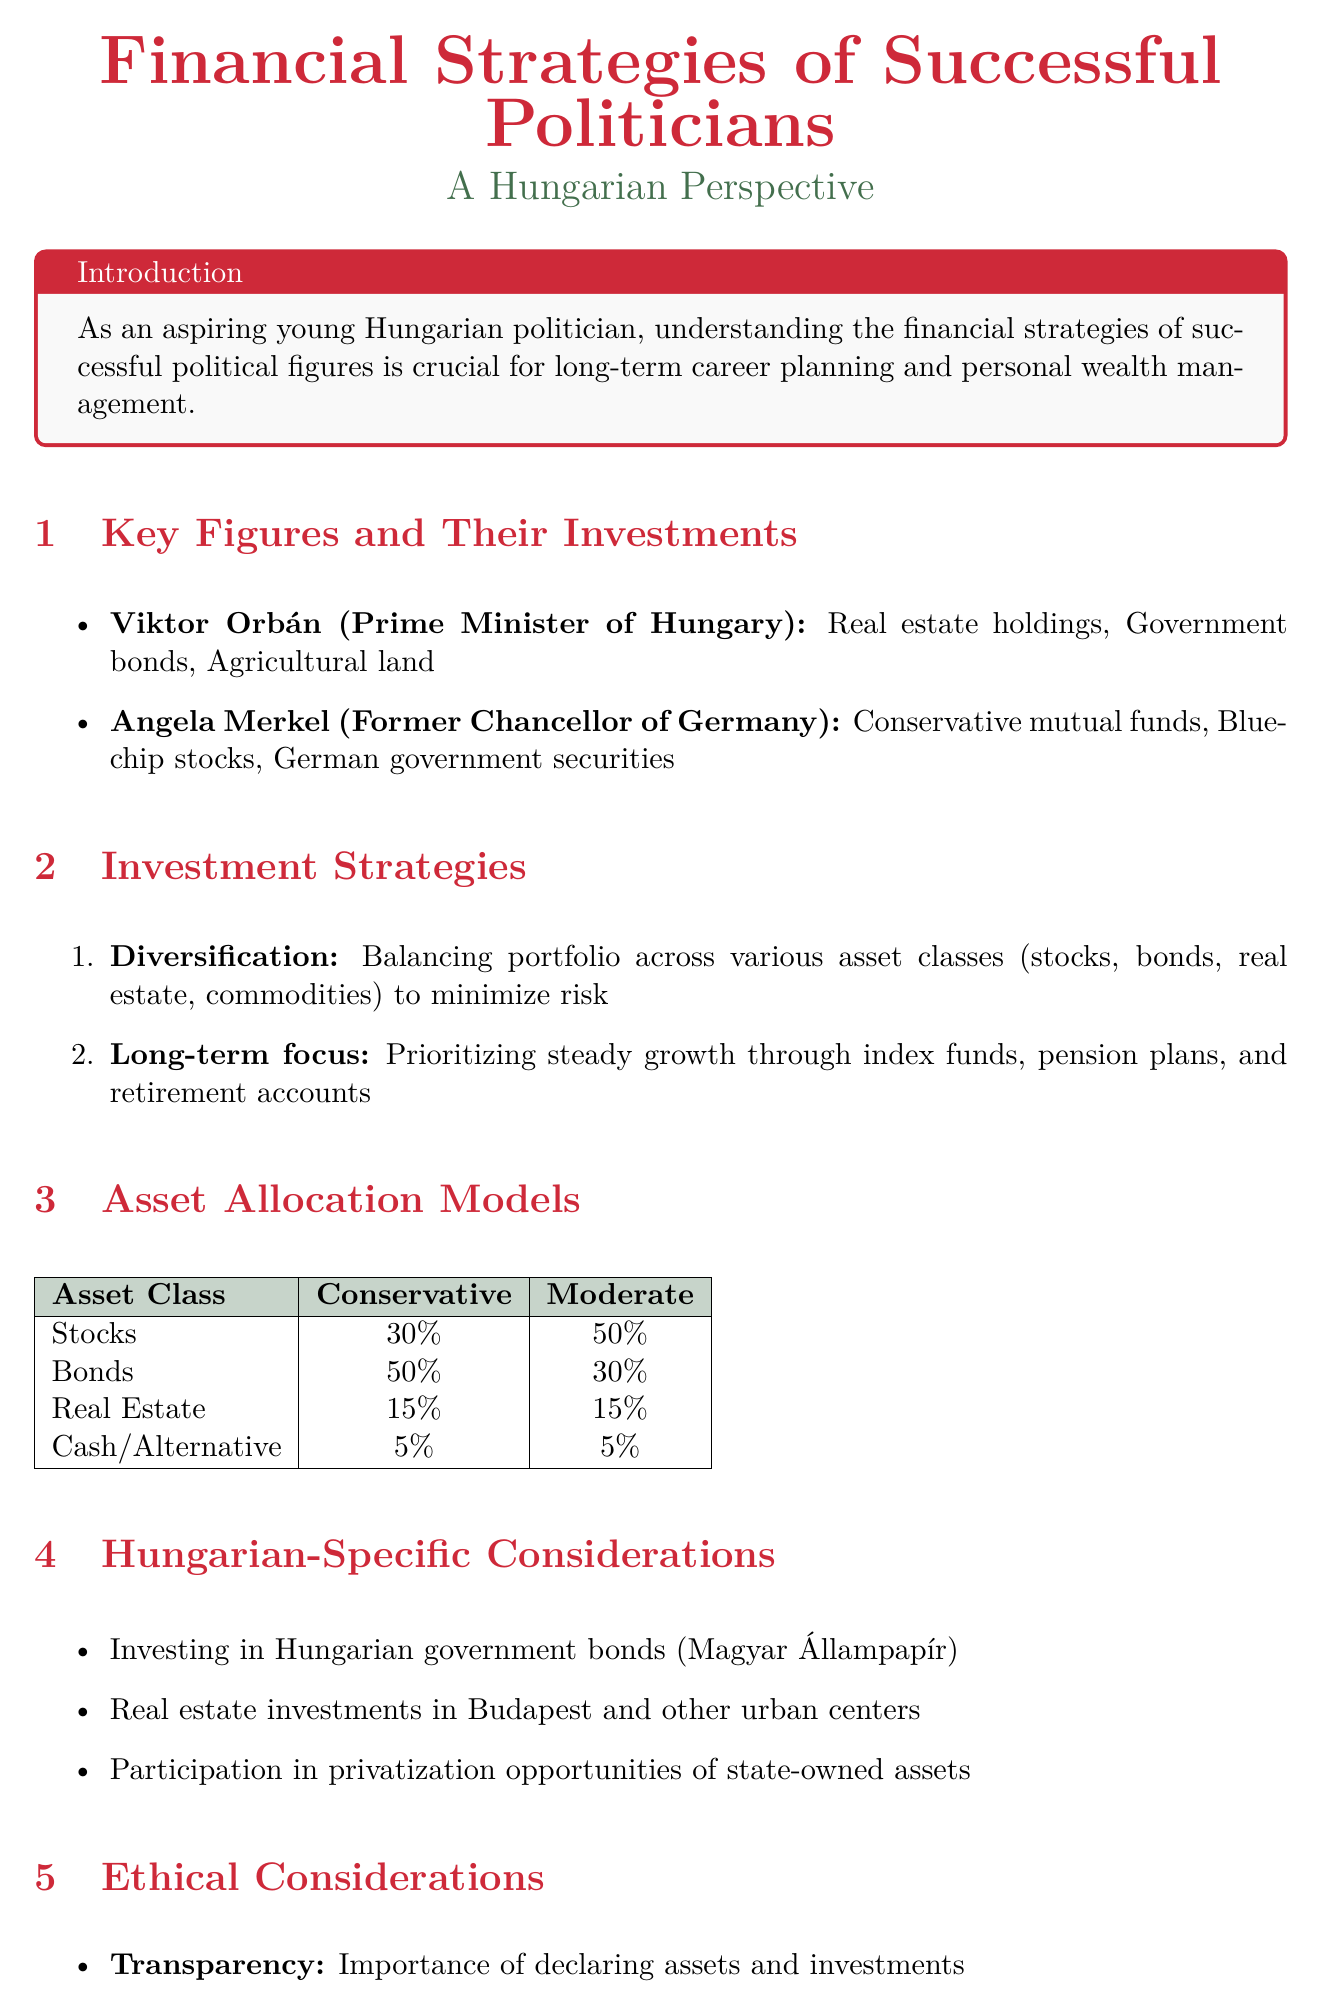What are Viktor Orbán's notable investments? The notable investments of Viktor Orbán include real estate holdings, government bonds, and agricultural land.
Answer: Real estate holdings, government bonds, agricultural land What percentage of the conservative model is allocated to bonds? The conservative model of asset allocation shows that 50% is allocated to bonds.
Answer: 50% Which investment strategy prioritizes steady growth? The investment strategy that prioritizes steady growth over speculative short-term gains is long-term focus.
Answer: Long-term focus What is a unique Hungarian-specific consideration mentioned in the report? The report highlights investing in Hungarian government bonds (Magyar Állampapír) as a unique consideration for Hungarian investors.
Answer: Investing in Hungarian government bonds What is the key takeaway from the conclusion? The key takeaway emphasizes the importance of emulating successful politicians' financial strategies while maintaining ethical standards.
Answer: Emulating successful politicians' financial strategies Which former political figure is mentioned alongside Viktor Orbán? The document mentions Angela Merkel as a former political figure alongside Viktor Orbán.
Answer: Angela Merkel What is the investment strategy that minimizes risk? The investment strategy focused on minimizing risk through balancing a portfolio is diversification.
Answer: Diversification What is the recommended allocation for cash in the conservative model? The conservative asset allocation model recommends a 5% allocation for cash.
Answer: 5% 